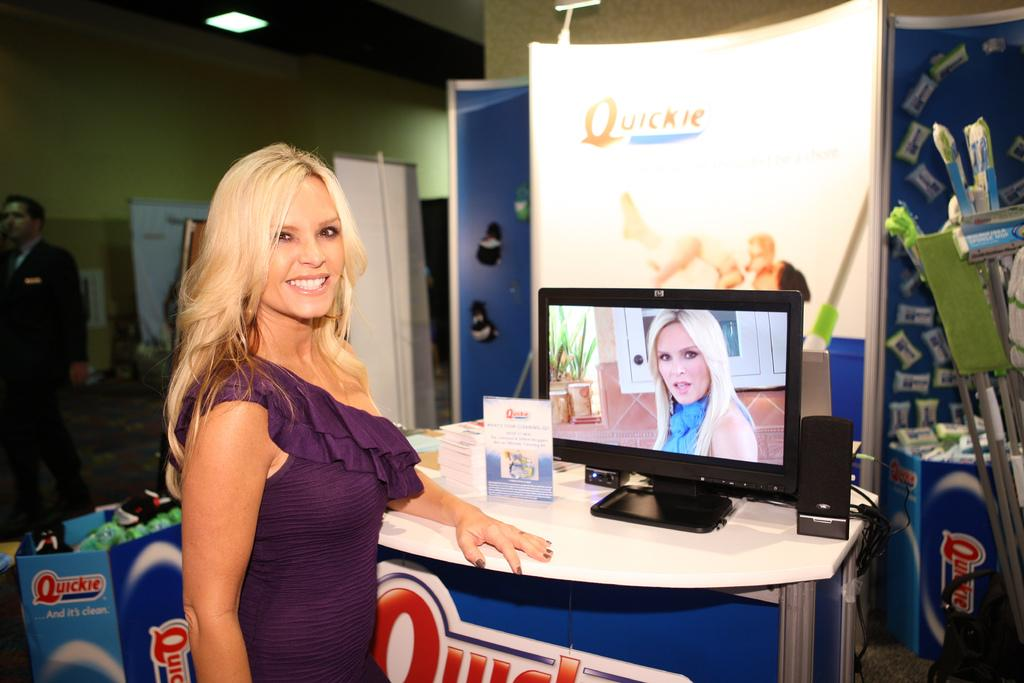<image>
Write a terse but informative summary of the picture. A woman stands in front of a display with a sign that says "quickie." 